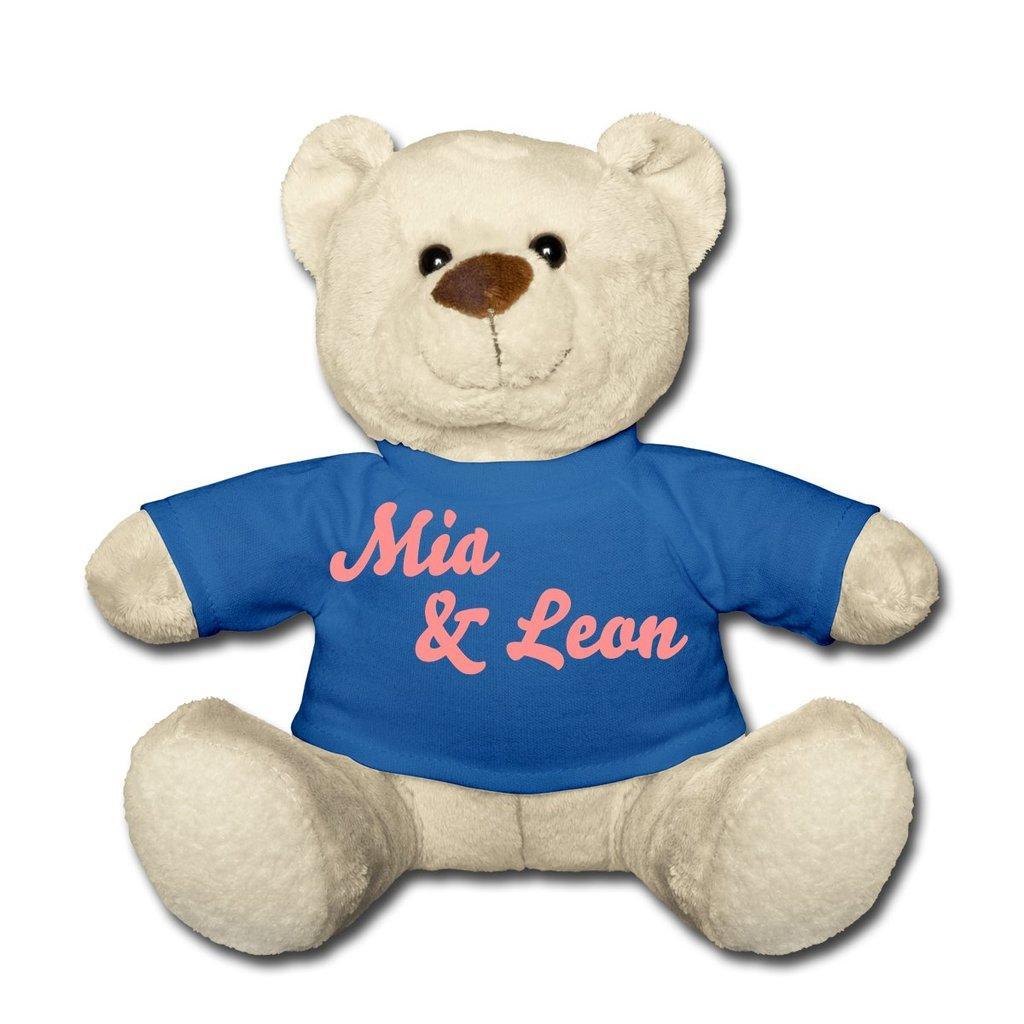In one or two sentences, can you explain what this image depicts? There is a white teddy wearing a blue t shirt. The background is white. 